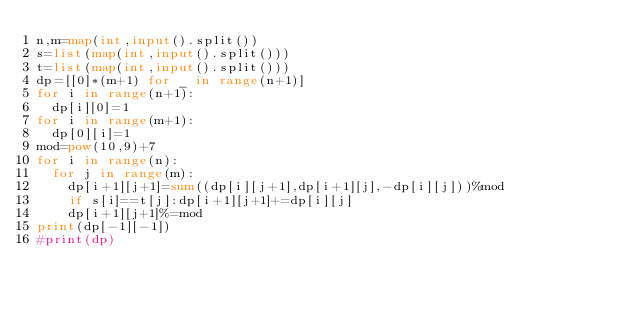Convert code to text. <code><loc_0><loc_0><loc_500><loc_500><_Python_>n,m=map(int,input().split())
s=list(map(int,input().split()))
t=list(map(int,input().split()))
dp=[[0]*(m+1) for _ in range(n+1)]
for i in range(n+1):
  dp[i][0]=1
for i in range(m+1):
  dp[0][i]=1
mod=pow(10,9)+7
for i in range(n):
  for j in range(m):
    dp[i+1][j+1]=sum((dp[i][j+1],dp[i+1][j],-dp[i][j]))%mod
    if s[i]==t[j]:dp[i+1][j+1]+=dp[i][j]
    dp[i+1][j+1]%=mod
print(dp[-1][-1])
#print(dp)</code> 